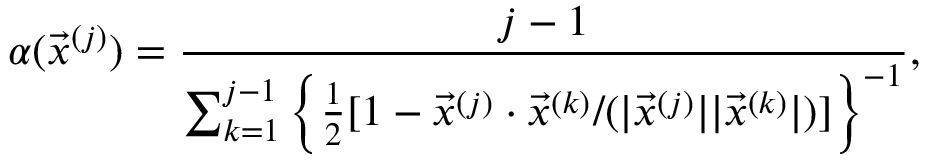<formula> <loc_0><loc_0><loc_500><loc_500>\alpha ( \vec { x } ^ { ( j ) } ) = \frac { j - 1 } { \sum _ { k = 1 } ^ { j - 1 } \left \{ \frac { 1 } { 2 } [ 1 - \vec { x } ^ { ( j ) } \cdot \vec { x } ^ { ( k ) } / ( | \vec { x } ^ { ( j ) } | | \vec { x } ^ { ( k ) } | ) ] \right \} ^ { - 1 } } ,</formula> 